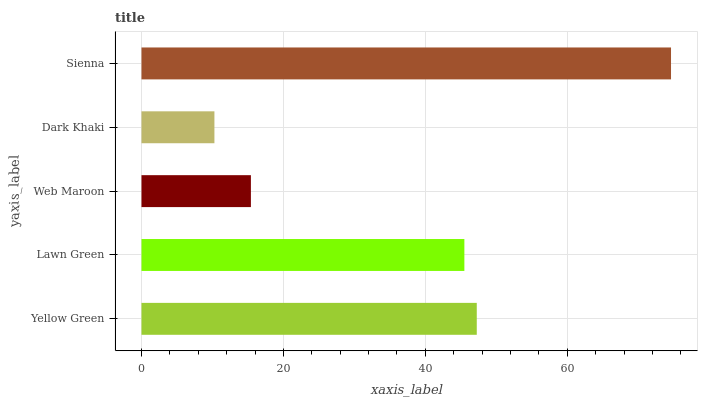Is Dark Khaki the minimum?
Answer yes or no. Yes. Is Sienna the maximum?
Answer yes or no. Yes. Is Lawn Green the minimum?
Answer yes or no. No. Is Lawn Green the maximum?
Answer yes or no. No. Is Yellow Green greater than Lawn Green?
Answer yes or no. Yes. Is Lawn Green less than Yellow Green?
Answer yes or no. Yes. Is Lawn Green greater than Yellow Green?
Answer yes or no. No. Is Yellow Green less than Lawn Green?
Answer yes or no. No. Is Lawn Green the high median?
Answer yes or no. Yes. Is Lawn Green the low median?
Answer yes or no. Yes. Is Sienna the high median?
Answer yes or no. No. Is Web Maroon the low median?
Answer yes or no. No. 